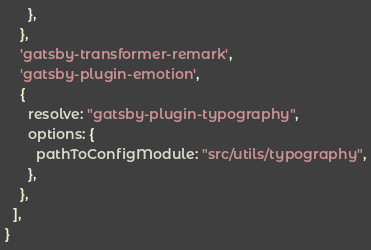Convert code to text. <code><loc_0><loc_0><loc_500><loc_500><_JavaScript_>      },
    },
    'gatsby-transformer-remark',
    'gatsby-plugin-emotion',
    {
      resolve: "gatsby-plugin-typography",
      options: {
        pathToConfigModule: "src/utils/typography",
      },
    },
  ],
}
</code> 